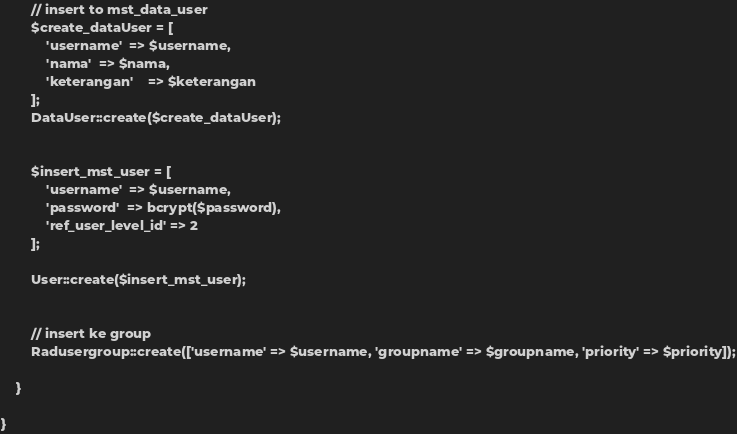Convert code to text. <code><loc_0><loc_0><loc_500><loc_500><_PHP_>
        // insert to mst_data_user
        $create_dataUser = [
            'username'  => $username,
            'nama'  => $nama,
            'keterangan'    => $keterangan
        ];
        DataUser::create($create_dataUser);


        $insert_mst_user = [
            'username'  => $username,
            'password'  => bcrypt($password),
            'ref_user_level_id' => 2
        ];

        User::create($insert_mst_user);


        // insert ke group
        Radusergroup::create(['username' => $username, 'groupname' => $groupname, 'priority' => $priority]);

    }

}</code> 